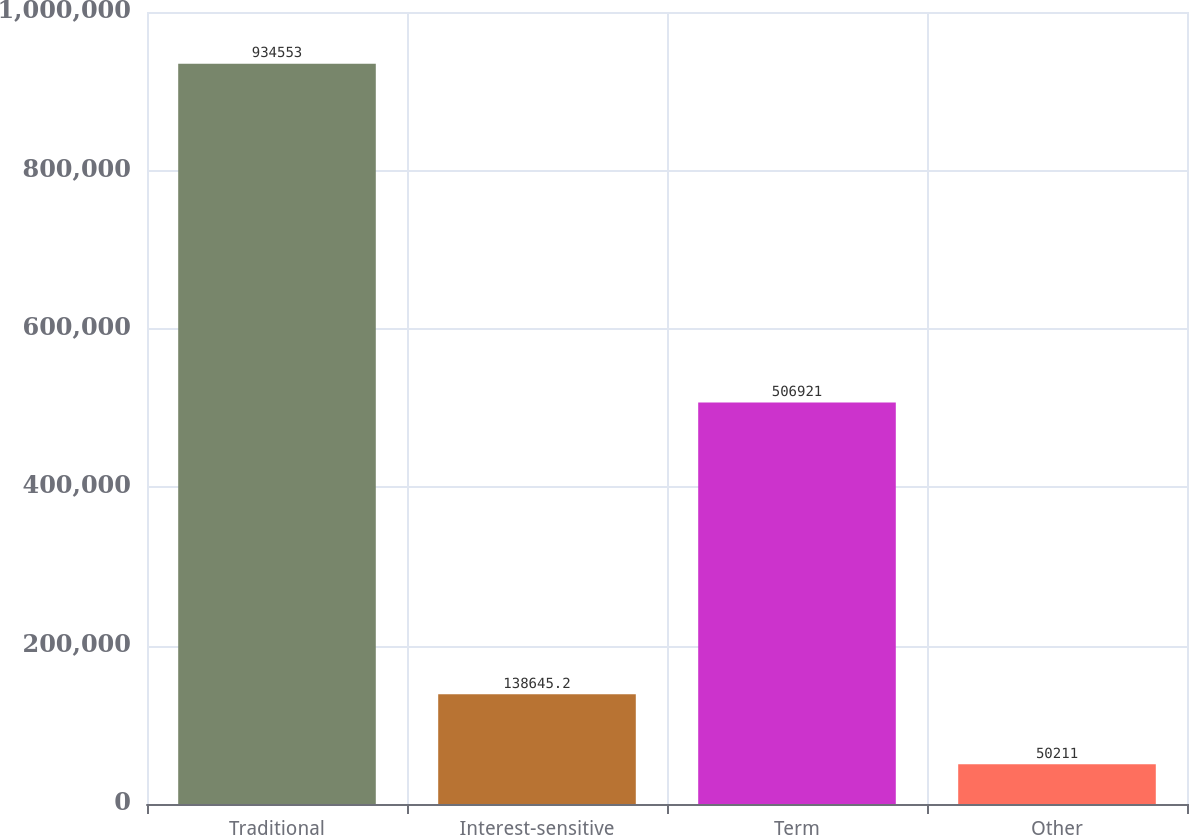Convert chart to OTSL. <chart><loc_0><loc_0><loc_500><loc_500><bar_chart><fcel>Traditional<fcel>Interest-sensitive<fcel>Term<fcel>Other<nl><fcel>934553<fcel>138645<fcel>506921<fcel>50211<nl></chart> 